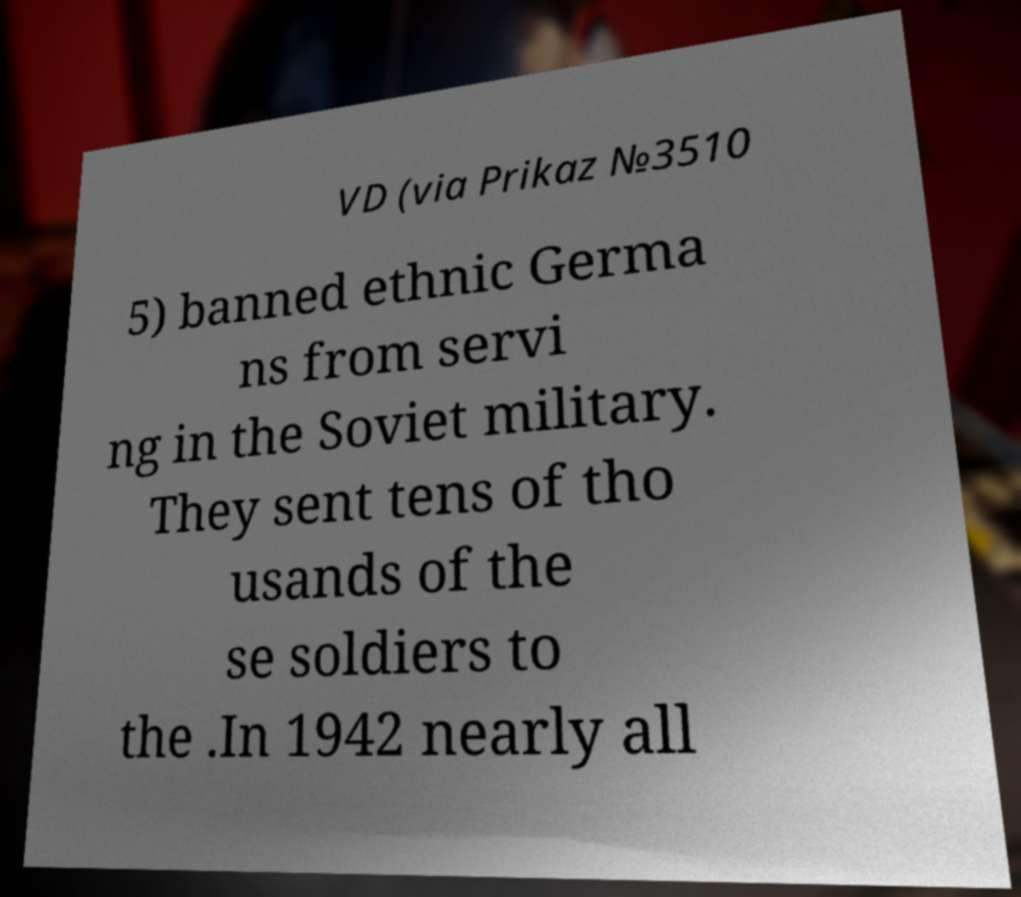What messages or text are displayed in this image? I need them in a readable, typed format. VD (via Prikaz №3510 5) banned ethnic Germa ns from servi ng in the Soviet military. They sent tens of tho usands of the se soldiers to the .In 1942 nearly all 